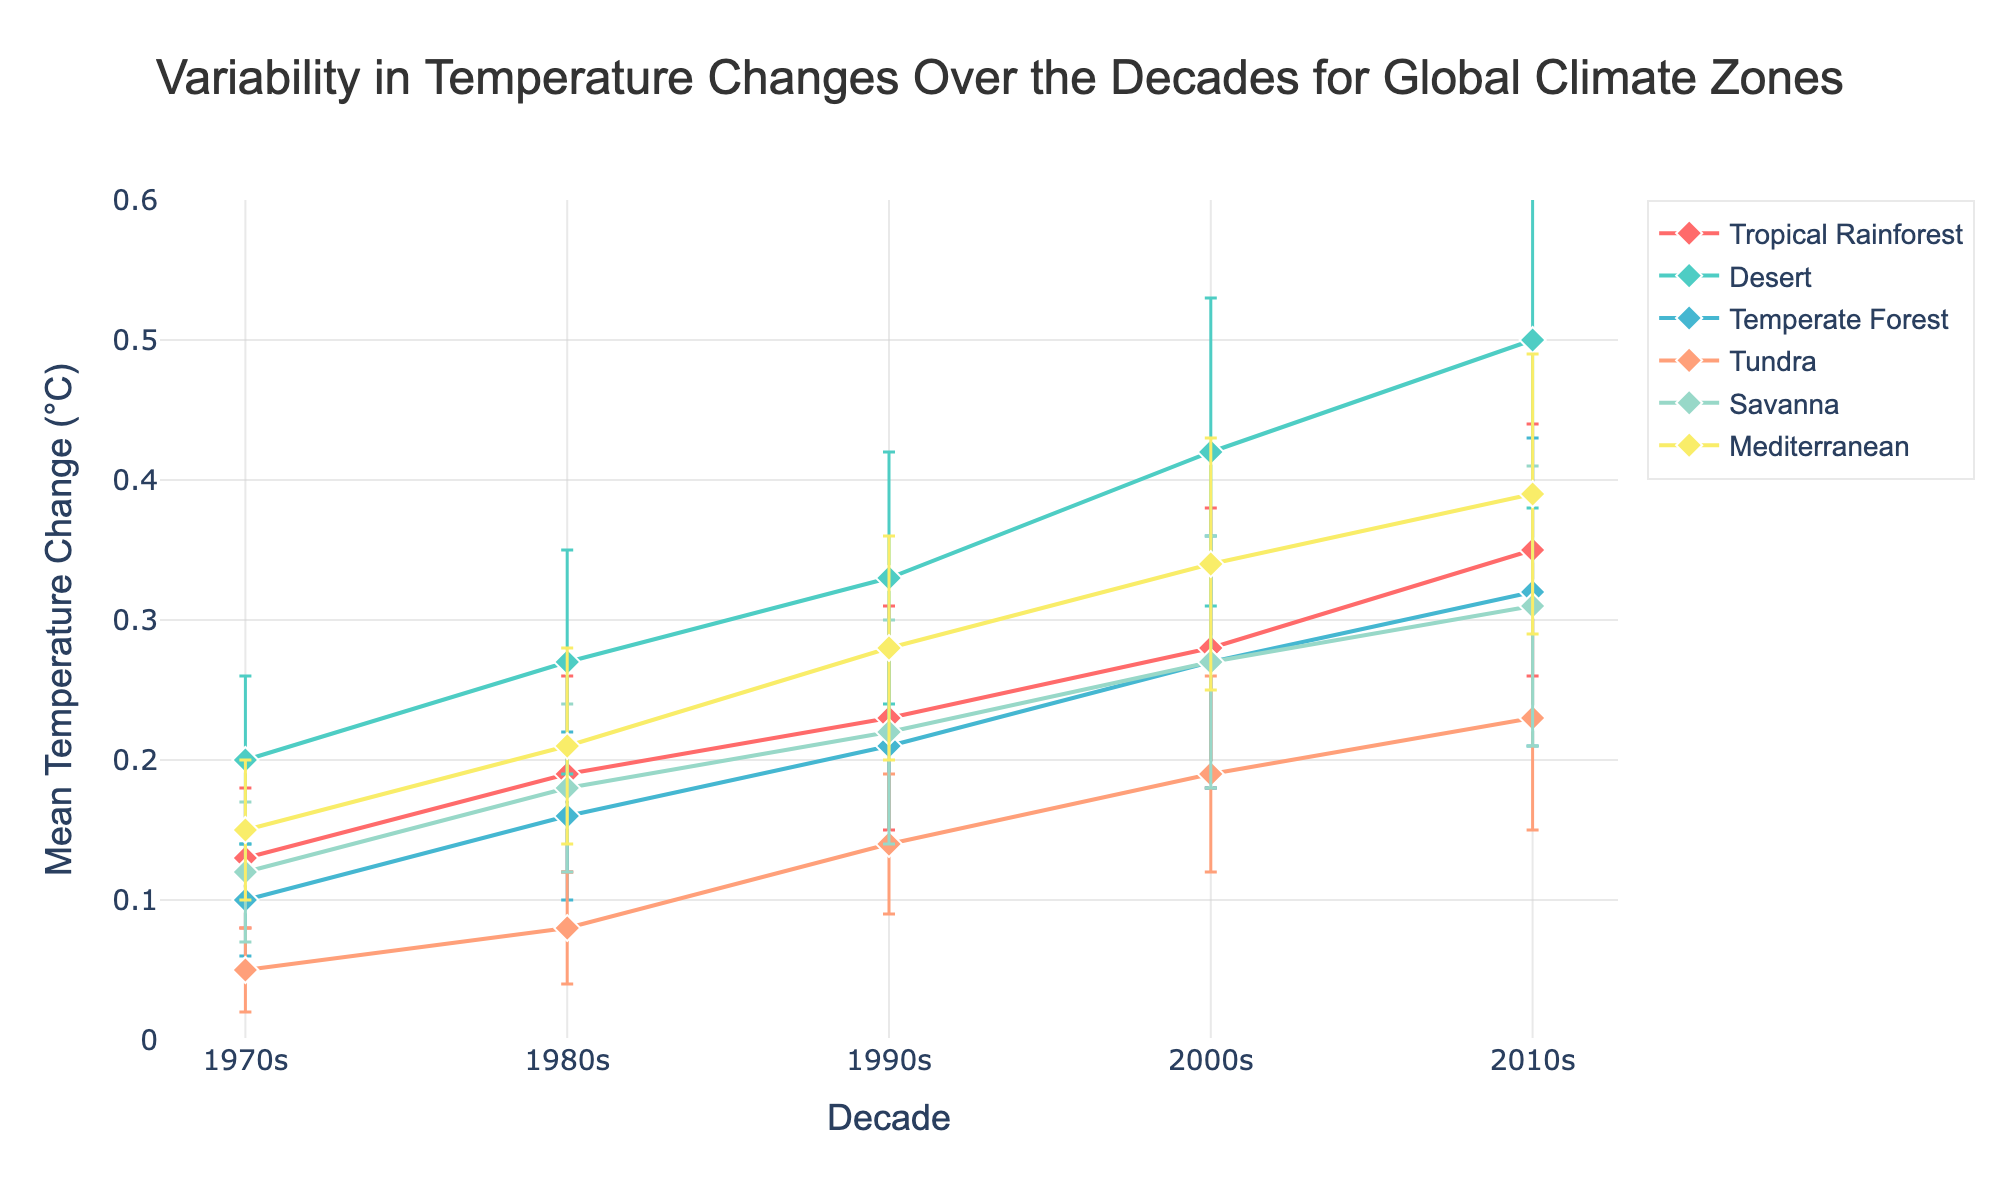What is the title of the plot? The title is located at the top center of the plot, and it reads, "Variability in Temperature Changes Over the Decades for Global Climate Zones".
Answer: Variability in Temperature Changes Over the Decades for Global Climate Zones How does the mean temperature change in the Desert region in the 2010s compare to that in the 1970s? The 2010s mean temperature change in the Desert region is 0.50°C, and the 1970s mean temperature change is 0.20°C. The difference is 0.50 - 0.20 = 0.30°C.
Answer: 0.30°C Which region had the smallest mean temperature change in the 1990s? By comparing the mean temperature changes for all regions in the 1990s, Tundra had the smallest mean change, which is 0.14°C.
Answer: Tundra Which region shows the highest variability in temperature change in the 2000s, and what is the standard deviation for this region? Variability can be inferred from the length of error bars. In the 2000s, the Desert region has the longest error bars representing the highest standard deviation, which is 0.11 as per the data.
Answer: Desert, 0.11 What is the trend in mean temperature change for the Tropical Rainforest region from the 1970s to the 2010s? The Tropical Rainforest region shows a clear increasing trend in mean temperature change: 0.13°C in the 1970s, 0.19°C in the 1980s, 0.23°C in the 1990s, 0.28°C in the 2000s, and 0.35°C in the 2010s.
Answer: Increasing Which two regions have the closest mean temperature change values in the 1980s? Looking at the mean temperature changes for all regions in the 1980s: Tropical Rainforest (0.19°C), Desert (0.27°C), Temperate Forest (0.16°C), Tundra (0.08°C), Savanna (0.18°C), Mediterranean (0.21°C). Tropical Rainforest (0.19°C) and Savanna (0.18°C) have the closest values.
Answer: Tropical Rainforest and Savanna From the plot, which region has the most consistent mean temperature change over the decades? Consistency can be inferred from similar mean values and small error bars. The Tropical Rainforest region has relatively small and consistent error bars over the decades, indicating consistent mean temperature change.
Answer: Tropical Rainforest Compare the mean temperature changes for the Mediterranean region between the 1970s and 2010s, and calculate the percentage increase. The mean temperature change in the Mediterranean region was 0.15°C in the 1970s and 0.39°C in the 2010s. The increase is 0.39 - 0.15 = 0.24°C. The percentage increase is (0.24/0.15) * 100 ≈ 160%.
Answer: 160% Which decade shows the maximum mean temperature change for the Temperate Forest region? By examining the data points for Temperate Forest across the decades: 0.10°C (1970s), 0.16°C (1980s), 0.21°C (1990s), 0.27°C (2000s), and 0.32°C (2010s). The maximum mean temperature change occurs in the 2010s.
Answer: 2010s 